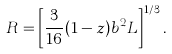<formula> <loc_0><loc_0><loc_500><loc_500>R = \left [ \frac { 3 } { 1 6 } ( 1 - z ) b ^ { 2 } L \right ] ^ { 1 / 3 } .</formula> 